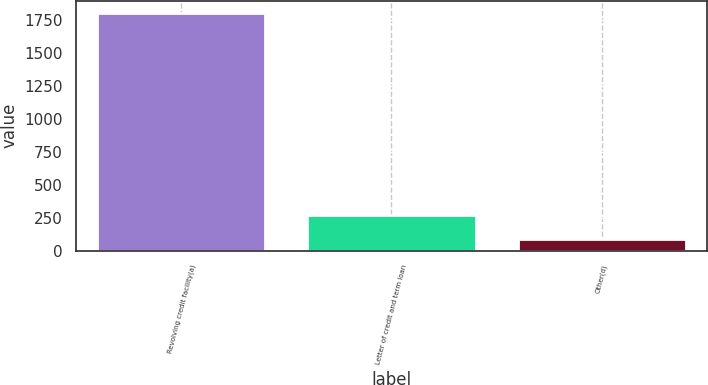Convert chart. <chart><loc_0><loc_0><loc_500><loc_500><bar_chart><fcel>Revolving credit facility(a)<fcel>Letter of credit and term loan<fcel>Other(d)<nl><fcel>1803<fcel>272<fcel>91<nl></chart> 